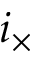Convert formula to latex. <formula><loc_0><loc_0><loc_500><loc_500>i _ { \times }</formula> 